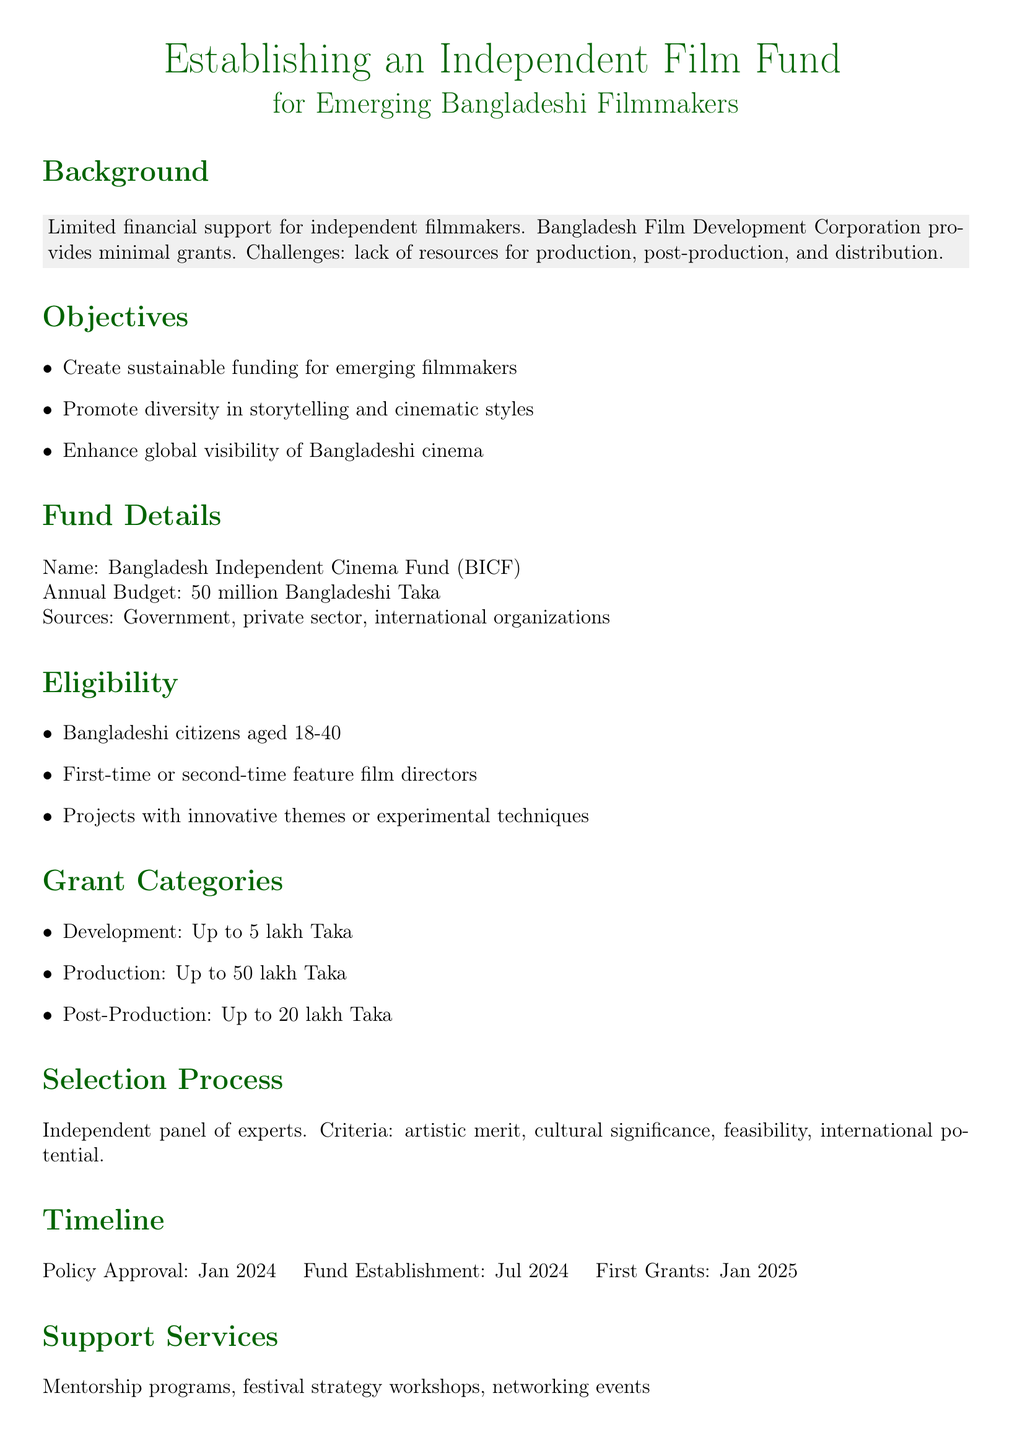What is the annual budget for the fund? The document states that the annual budget for the fund is 50 million Bangladeshi Taka.
Answer: 50 million Bangladeshi Taka Who proposed the policy? The proposal is attributed to a Bangladeshi filmmaker aspiring for national recognition.
Answer: A Bangladeshi filmmaker What is the name of the fund? The fund is referred to as the Bangladesh Independent Cinema Fund (BICF).
Answer: Bangladesh Independent Cinema Fund (BICF) What is the age range for eligibility? The document specifies that eligible filmmakers must be 18-40 years old.
Answer: 18-40 years old How many categories of grants are mentioned? The fund outlines three grant categories: Development, Production, and Post-Production.
Answer: Three categories What is the expected outcome regarding independent films? The document states that the expected outcome includes an increase in independent films produced annually.
Answer: Increase in independent films What is required for project eligibility? The document notes that projects should have innovative themes or experimental techniques for eligibility.
Answer: Innovative themes or experimental techniques What is the timeline for the first grants? According to the document, the first grants are expected to be issued in January 2025.
Answer: January 2025 Who will oversee the selection process? An independent panel of experts will oversee the selection process for grants.
Answer: Independent panel of experts 